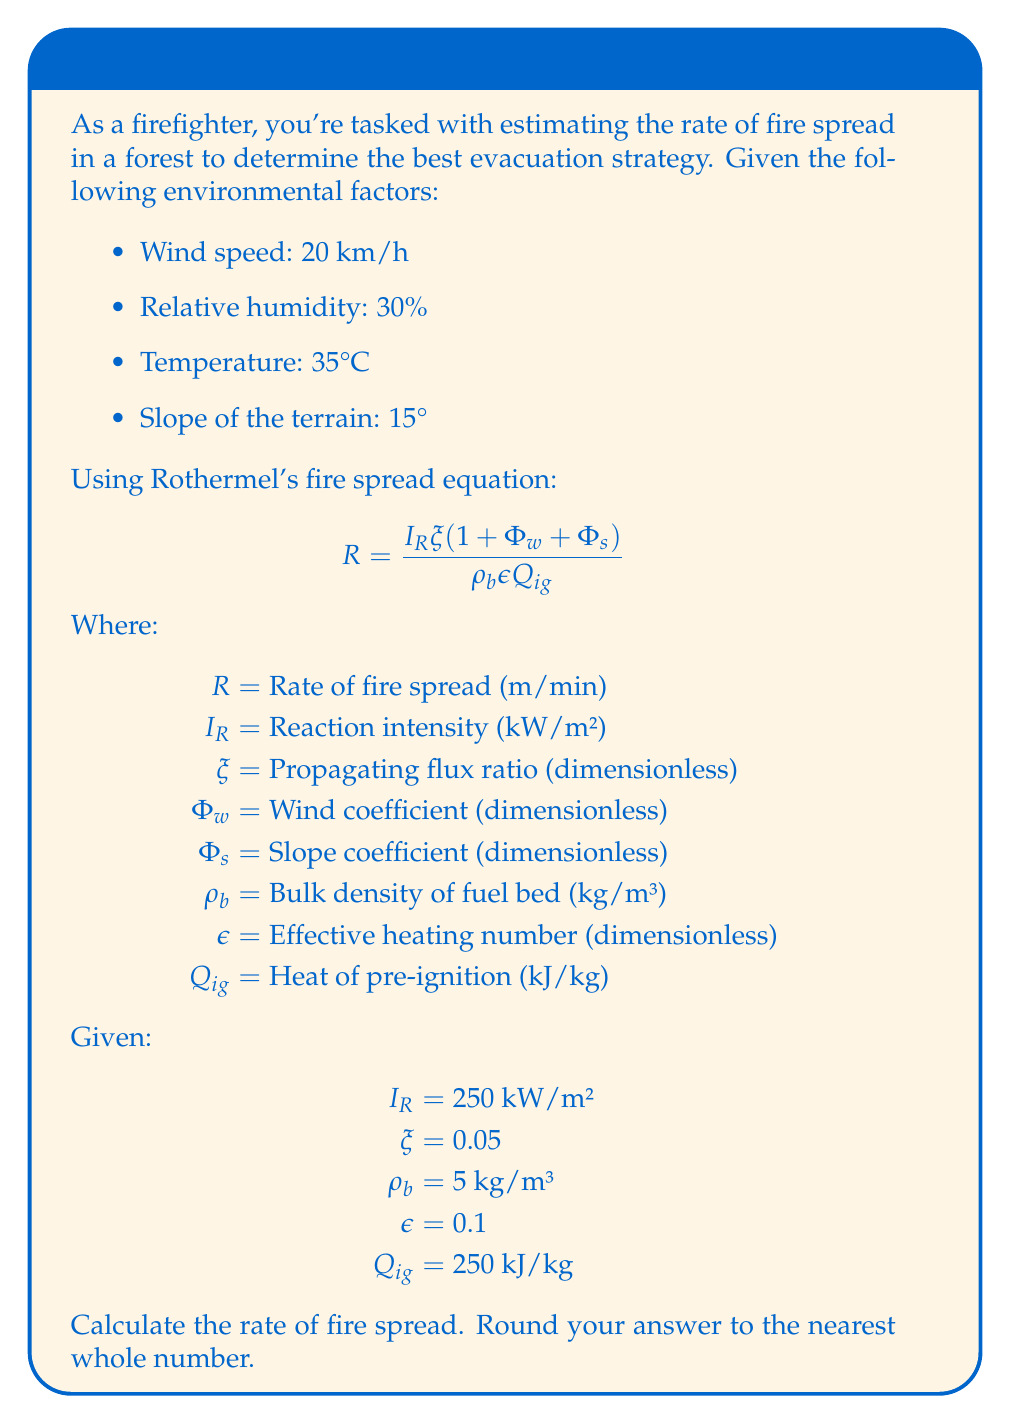Teach me how to tackle this problem. To solve this problem, we need to follow these steps:

1. Calculate the wind coefficient $\Phi_w$:
   $\Phi_w = 5.275 \beta^{-0.3} (\frac{U}{U_{max}})^2$
   Where $\beta = 0.5$ (packing ratio), $U = 20$ km/h (wind speed), and $U_{max} = 60$ km/h (maximum wind speed)
   $\Phi_w = 5.275 (0.5)^{-0.3} (\frac{20}{60})^2 = 2.94$

2. Calculate the slope coefficient $\Phi_s$:
   $\Phi_s = 5.275 \tan^2(\theta)$
   Where $\theta = 15°$
   $\Phi_s = 5.275 \tan^2(15°) = 0.36$

3. Substitute the values into Rothermel's equation:
   $R = \frac{250 \cdot 0.05 (1 + 2.94 + 0.36)}{5 \cdot 0.1 \cdot 250}$

4. Simplify and calculate:
   $R = \frac{250 \cdot 0.05 \cdot 4.3}{125} = 4.3$ m/min

5. Round to the nearest whole number:
   $R \approx 4$ m/min
Answer: 4 m/min 